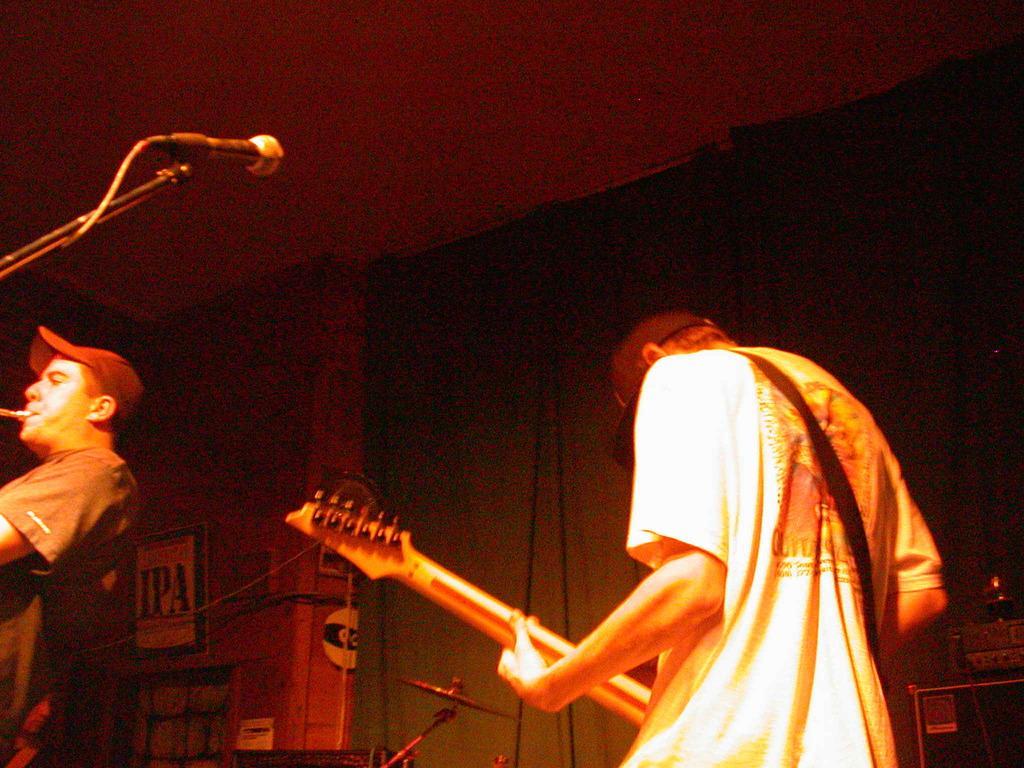Could you give a brief overview of what you see in this image? In this picture we can see two persons. He is playing guitar. This is mike. On the background there is a wall. And these are some musical instruments. 